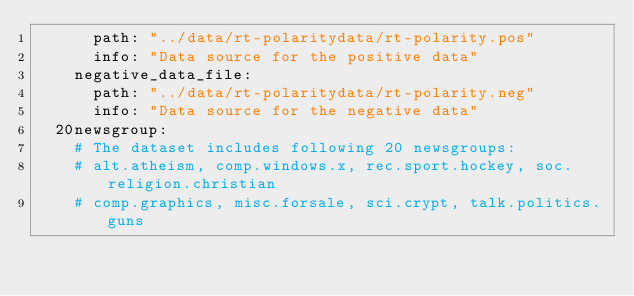Convert code to text. <code><loc_0><loc_0><loc_500><loc_500><_YAML_>      path: "../data/rt-polaritydata/rt-polarity.pos"
      info: "Data source for the positive data"
    negative_data_file:
      path: "../data/rt-polaritydata/rt-polarity.neg"
      info: "Data source for the negative data"
  20newsgroup:
    # The dataset includes following 20 newsgroups:
    # alt.atheism, comp.windows.x, rec.sport.hockey, soc.religion.christian
    # comp.graphics, misc.forsale, sci.crypt, talk.politics.guns</code> 